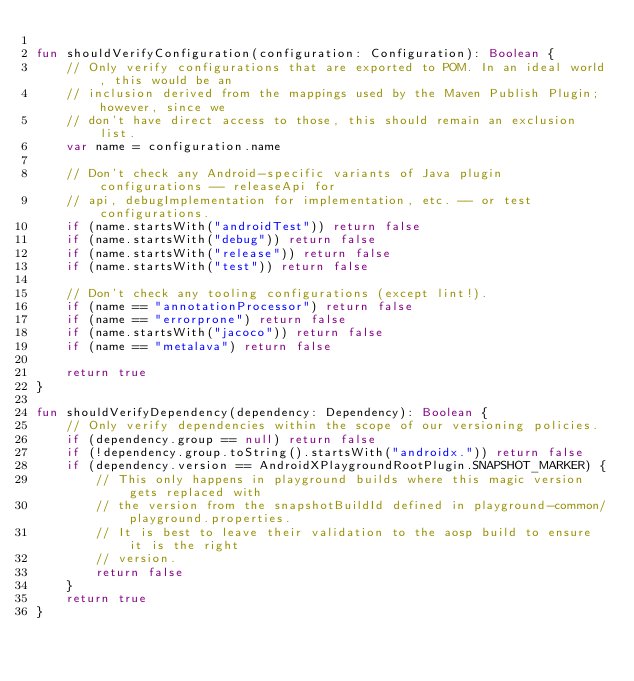<code> <loc_0><loc_0><loc_500><loc_500><_Kotlin_>
fun shouldVerifyConfiguration(configuration: Configuration): Boolean {
    // Only verify configurations that are exported to POM. In an ideal world, this would be an
    // inclusion derived from the mappings used by the Maven Publish Plugin; however, since we
    // don't have direct access to those, this should remain an exclusion list.
    var name = configuration.name

    // Don't check any Android-specific variants of Java plugin configurations -- releaseApi for
    // api, debugImplementation for implementation, etc. -- or test configurations.
    if (name.startsWith("androidTest")) return false
    if (name.startsWith("debug")) return false
    if (name.startsWith("release")) return false
    if (name.startsWith("test")) return false

    // Don't check any tooling configurations (except lint!).
    if (name == "annotationProcessor") return false
    if (name == "errorprone") return false
    if (name.startsWith("jacoco")) return false
    if (name == "metalava") return false

    return true
}

fun shouldVerifyDependency(dependency: Dependency): Boolean {
    // Only verify dependencies within the scope of our versioning policies.
    if (dependency.group == null) return false
    if (!dependency.group.toString().startsWith("androidx.")) return false
    if (dependency.version == AndroidXPlaygroundRootPlugin.SNAPSHOT_MARKER) {
        // This only happens in playground builds where this magic version gets replaced with
        // the version from the snapshotBuildId defined in playground-common/playground.properties.
        // It is best to leave their validation to the aosp build to ensure it is the right
        // version.
        return false
    }
    return true
}
</code> 